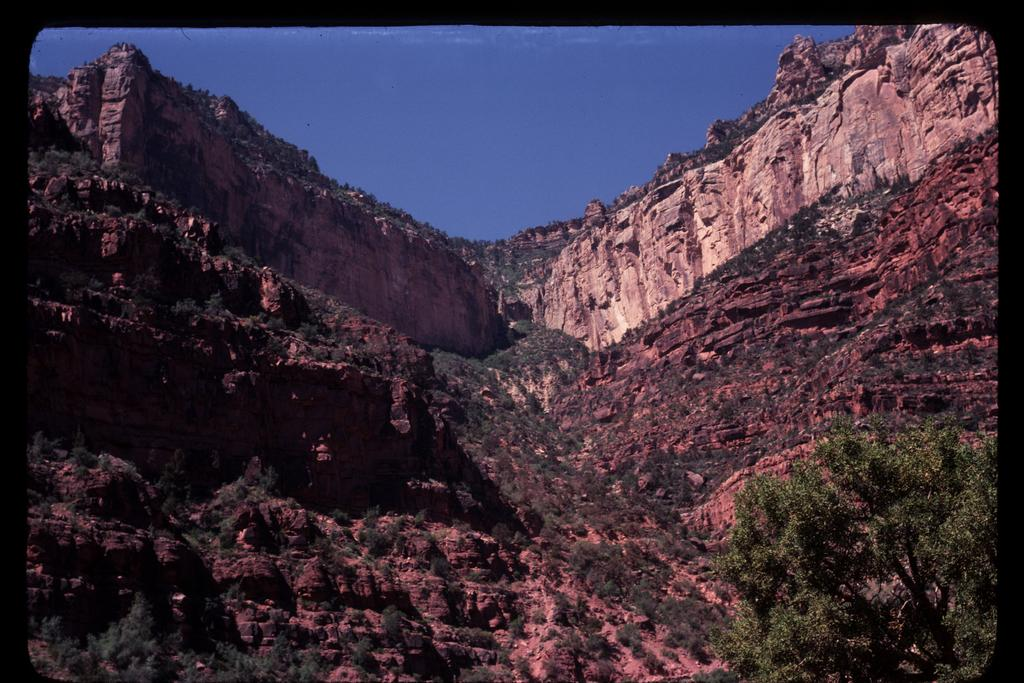What type of vegetation is located at the bottom right corner of the image? There is a tree at the bottom right corner of the image. What type of natural formation can be seen in the background of the image? There is a mountain in the background of the image. What color is the sky visible at the top of the image? The sky is blue at the top of the image. How many ducks are swimming in the water near the tree in the image? There are no ducks present in the image; it only features a tree, a mountain, and a blue sky. Are there any babies visible in the image? There are no babies present in the image. 